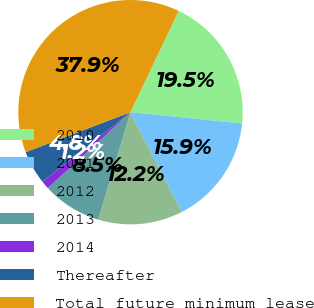Convert chart. <chart><loc_0><loc_0><loc_500><loc_500><pie_chart><fcel>2010<fcel>2011<fcel>2012<fcel>2013<fcel>2014<fcel>Thereafter<fcel>Total future minimum lease<nl><fcel>19.53%<fcel>15.86%<fcel>12.19%<fcel>8.52%<fcel>1.18%<fcel>4.85%<fcel>37.87%<nl></chart> 